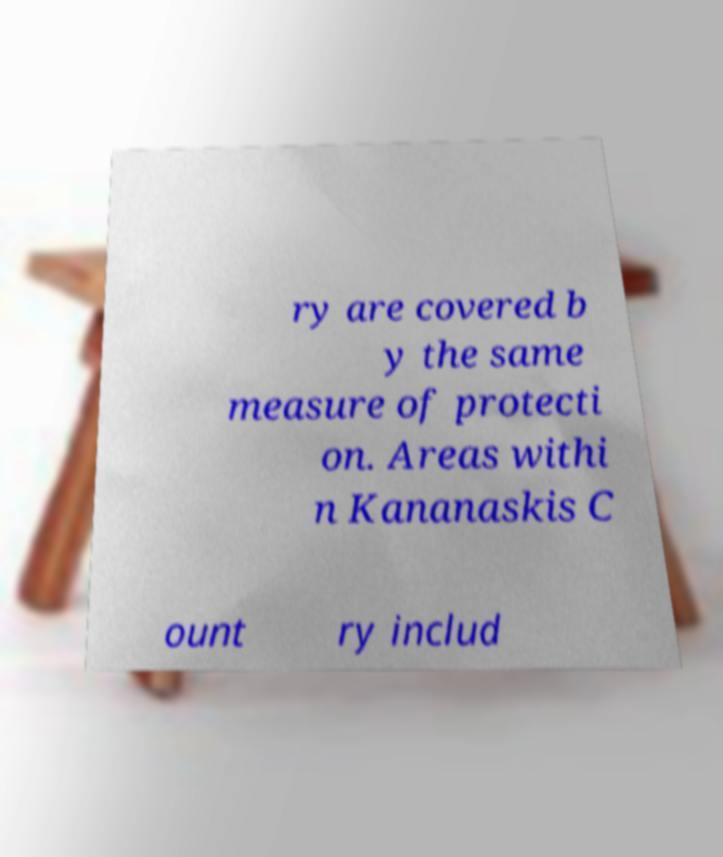For documentation purposes, I need the text within this image transcribed. Could you provide that? ry are covered b y the same measure of protecti on. Areas withi n Kananaskis C ount ry includ 